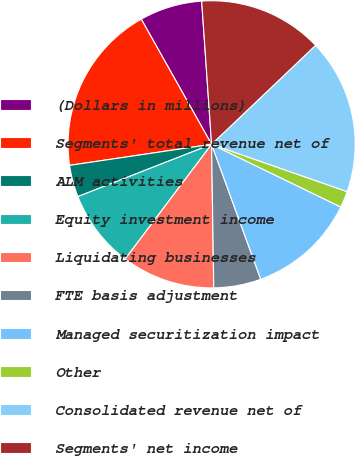Convert chart. <chart><loc_0><loc_0><loc_500><loc_500><pie_chart><fcel>(Dollars in millions)<fcel>Segments' total revenue net of<fcel>ALM activities<fcel>Equity investment income<fcel>Liquidating businesses<fcel>FTE basis adjustment<fcel>Managed securitization impact<fcel>Other<fcel>Consolidated revenue net of<fcel>Segments' net income<nl><fcel>7.05%<fcel>19.19%<fcel>3.59%<fcel>8.79%<fcel>10.52%<fcel>5.32%<fcel>12.25%<fcel>1.85%<fcel>17.45%<fcel>13.99%<nl></chart> 